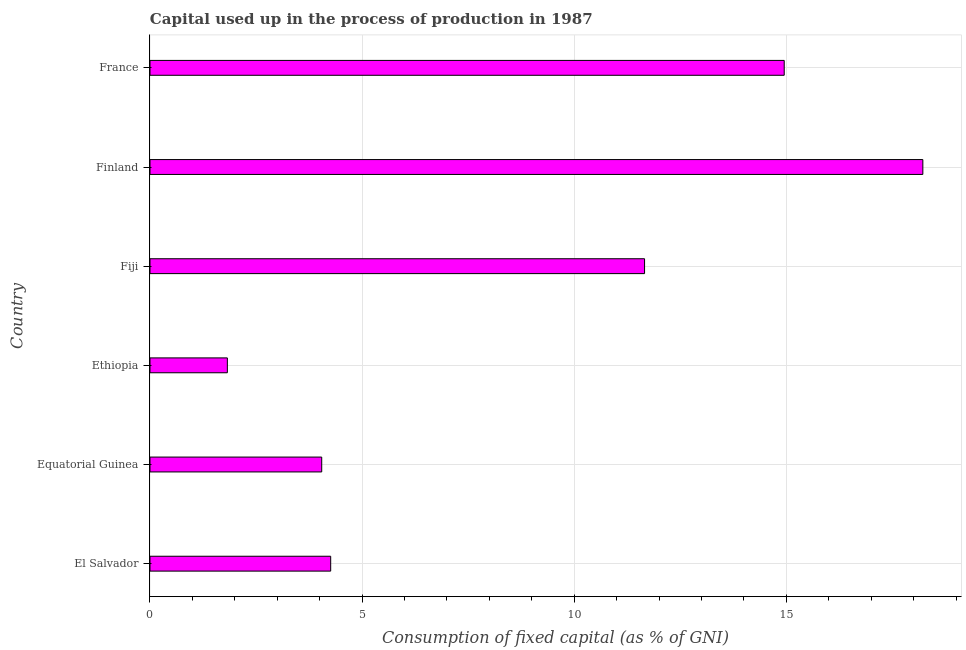Does the graph contain any zero values?
Provide a succinct answer. No. Does the graph contain grids?
Offer a very short reply. Yes. What is the title of the graph?
Offer a terse response. Capital used up in the process of production in 1987. What is the label or title of the X-axis?
Give a very brief answer. Consumption of fixed capital (as % of GNI). What is the label or title of the Y-axis?
Your response must be concise. Country. What is the consumption of fixed capital in France?
Keep it short and to the point. 14.95. Across all countries, what is the maximum consumption of fixed capital?
Keep it short and to the point. 18.22. Across all countries, what is the minimum consumption of fixed capital?
Make the answer very short. 1.82. In which country was the consumption of fixed capital minimum?
Provide a short and direct response. Ethiopia. What is the sum of the consumption of fixed capital?
Your answer should be very brief. 54.95. What is the difference between the consumption of fixed capital in Equatorial Guinea and France?
Provide a short and direct response. -10.9. What is the average consumption of fixed capital per country?
Your answer should be compact. 9.16. What is the median consumption of fixed capital?
Your response must be concise. 7.96. In how many countries, is the consumption of fixed capital greater than 1 %?
Your response must be concise. 6. What is the ratio of the consumption of fixed capital in Finland to that in France?
Offer a very short reply. 1.22. Is the consumption of fixed capital in El Salvador less than that in Finland?
Offer a very short reply. Yes. What is the difference between the highest and the second highest consumption of fixed capital?
Keep it short and to the point. 3.27. Is the sum of the consumption of fixed capital in Equatorial Guinea and Finland greater than the maximum consumption of fixed capital across all countries?
Provide a short and direct response. Yes. What is the difference between the highest and the lowest consumption of fixed capital?
Offer a very short reply. 16.39. In how many countries, is the consumption of fixed capital greater than the average consumption of fixed capital taken over all countries?
Offer a terse response. 3. How many bars are there?
Your answer should be compact. 6. Are all the bars in the graph horizontal?
Keep it short and to the point. Yes. What is the difference between two consecutive major ticks on the X-axis?
Make the answer very short. 5. What is the Consumption of fixed capital (as % of GNI) of El Salvador?
Your answer should be compact. 4.26. What is the Consumption of fixed capital (as % of GNI) of Equatorial Guinea?
Provide a succinct answer. 4.05. What is the Consumption of fixed capital (as % of GNI) in Ethiopia?
Your answer should be very brief. 1.82. What is the Consumption of fixed capital (as % of GNI) in Fiji?
Your answer should be compact. 11.66. What is the Consumption of fixed capital (as % of GNI) in Finland?
Give a very brief answer. 18.22. What is the Consumption of fixed capital (as % of GNI) in France?
Give a very brief answer. 14.95. What is the difference between the Consumption of fixed capital (as % of GNI) in El Salvador and Equatorial Guinea?
Offer a very short reply. 0.21. What is the difference between the Consumption of fixed capital (as % of GNI) in El Salvador and Ethiopia?
Make the answer very short. 2.44. What is the difference between the Consumption of fixed capital (as % of GNI) in El Salvador and Fiji?
Ensure brevity in your answer.  -7.4. What is the difference between the Consumption of fixed capital (as % of GNI) in El Salvador and Finland?
Your answer should be very brief. -13.96. What is the difference between the Consumption of fixed capital (as % of GNI) in El Salvador and France?
Offer a terse response. -10.69. What is the difference between the Consumption of fixed capital (as % of GNI) in Equatorial Guinea and Ethiopia?
Your answer should be compact. 2.22. What is the difference between the Consumption of fixed capital (as % of GNI) in Equatorial Guinea and Fiji?
Provide a short and direct response. -7.61. What is the difference between the Consumption of fixed capital (as % of GNI) in Equatorial Guinea and Finland?
Give a very brief answer. -14.17. What is the difference between the Consumption of fixed capital (as % of GNI) in Equatorial Guinea and France?
Give a very brief answer. -10.9. What is the difference between the Consumption of fixed capital (as % of GNI) in Ethiopia and Fiji?
Offer a very short reply. -9.83. What is the difference between the Consumption of fixed capital (as % of GNI) in Ethiopia and Finland?
Your answer should be very brief. -16.39. What is the difference between the Consumption of fixed capital (as % of GNI) in Ethiopia and France?
Offer a terse response. -13.13. What is the difference between the Consumption of fixed capital (as % of GNI) in Fiji and Finland?
Provide a succinct answer. -6.56. What is the difference between the Consumption of fixed capital (as % of GNI) in Fiji and France?
Your answer should be compact. -3.29. What is the difference between the Consumption of fixed capital (as % of GNI) in Finland and France?
Make the answer very short. 3.27. What is the ratio of the Consumption of fixed capital (as % of GNI) in El Salvador to that in Equatorial Guinea?
Offer a terse response. 1.05. What is the ratio of the Consumption of fixed capital (as % of GNI) in El Salvador to that in Ethiopia?
Your response must be concise. 2.34. What is the ratio of the Consumption of fixed capital (as % of GNI) in El Salvador to that in Fiji?
Give a very brief answer. 0.36. What is the ratio of the Consumption of fixed capital (as % of GNI) in El Salvador to that in Finland?
Offer a very short reply. 0.23. What is the ratio of the Consumption of fixed capital (as % of GNI) in El Salvador to that in France?
Your answer should be very brief. 0.28. What is the ratio of the Consumption of fixed capital (as % of GNI) in Equatorial Guinea to that in Ethiopia?
Give a very brief answer. 2.22. What is the ratio of the Consumption of fixed capital (as % of GNI) in Equatorial Guinea to that in Fiji?
Make the answer very short. 0.35. What is the ratio of the Consumption of fixed capital (as % of GNI) in Equatorial Guinea to that in Finland?
Give a very brief answer. 0.22. What is the ratio of the Consumption of fixed capital (as % of GNI) in Equatorial Guinea to that in France?
Make the answer very short. 0.27. What is the ratio of the Consumption of fixed capital (as % of GNI) in Ethiopia to that in Fiji?
Ensure brevity in your answer.  0.16. What is the ratio of the Consumption of fixed capital (as % of GNI) in Ethiopia to that in France?
Keep it short and to the point. 0.12. What is the ratio of the Consumption of fixed capital (as % of GNI) in Fiji to that in Finland?
Your answer should be very brief. 0.64. What is the ratio of the Consumption of fixed capital (as % of GNI) in Fiji to that in France?
Give a very brief answer. 0.78. What is the ratio of the Consumption of fixed capital (as % of GNI) in Finland to that in France?
Make the answer very short. 1.22. 